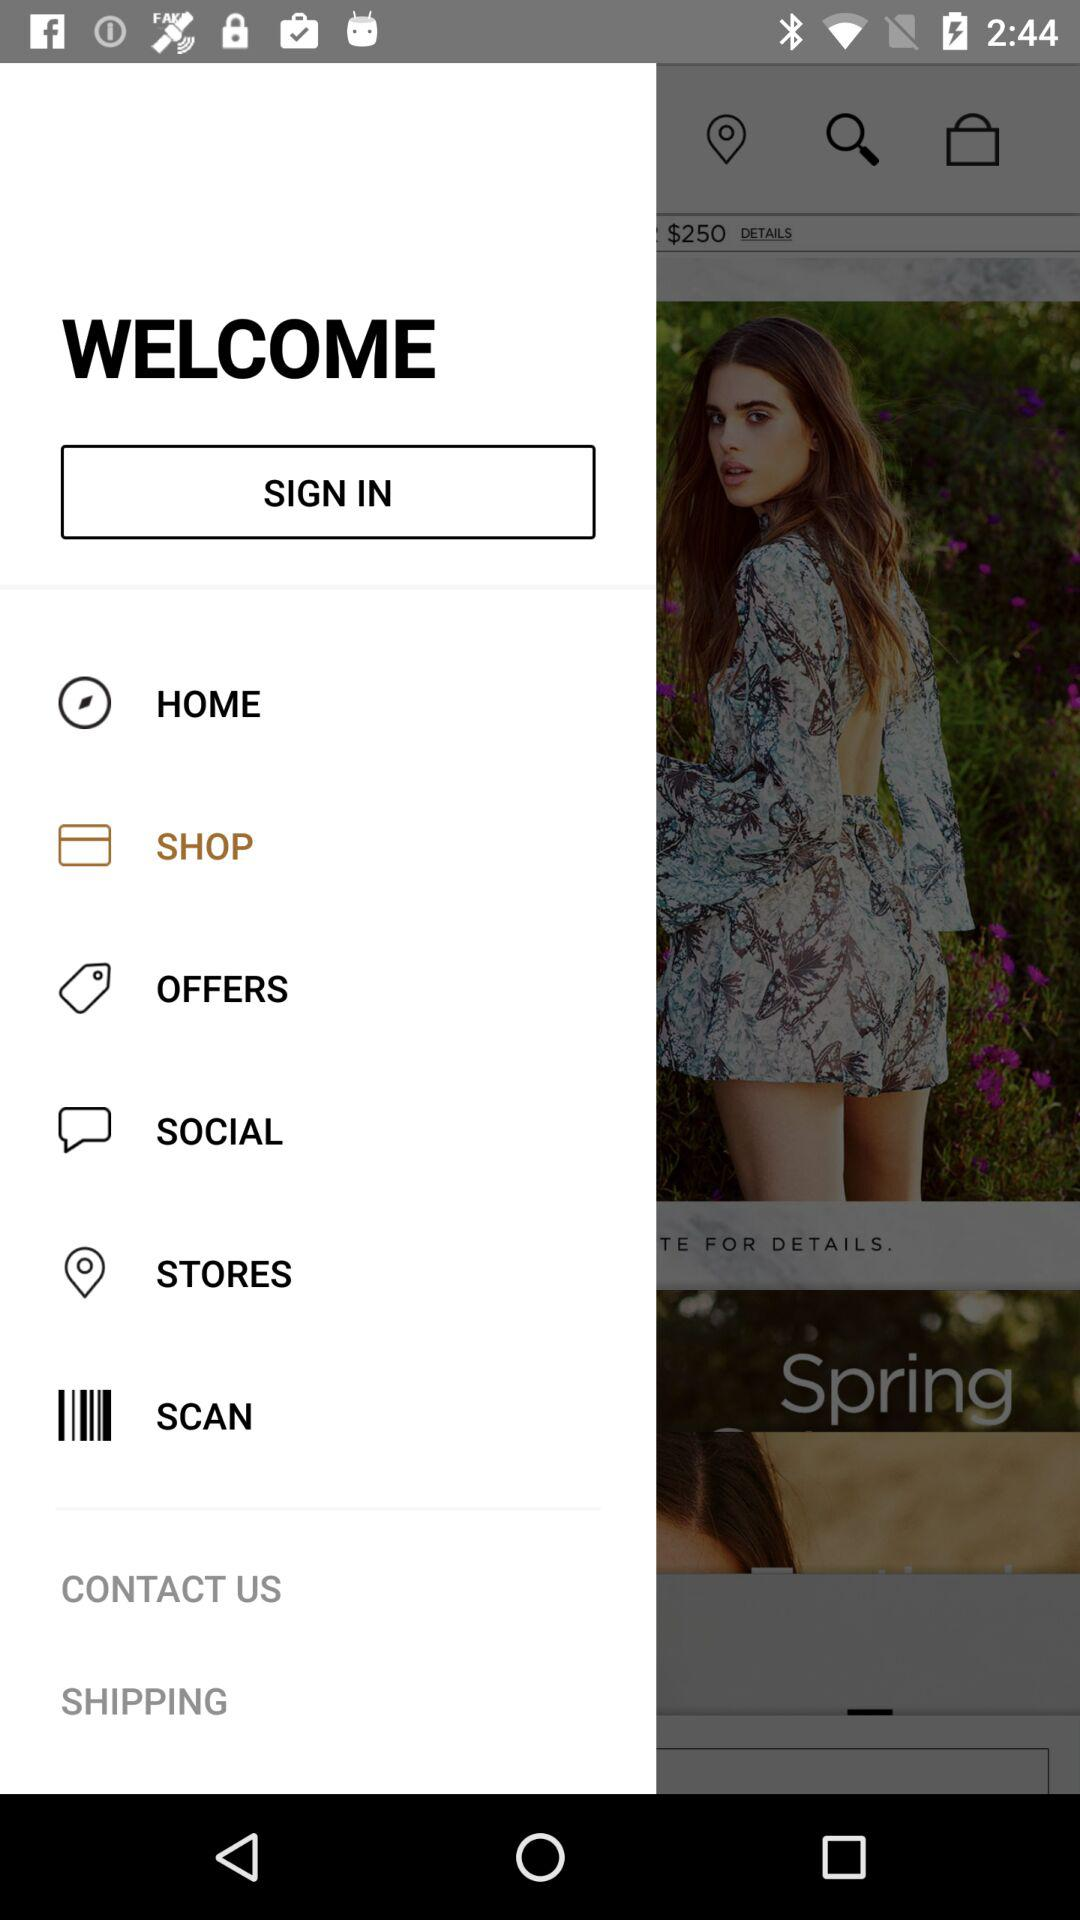What's the selected option? The selected option is "SHOP". 